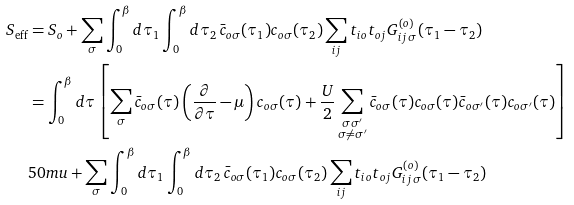Convert formula to latex. <formula><loc_0><loc_0><loc_500><loc_500>S _ { \text {eff} } & = S _ { o } + \sum _ { \sigma } \int _ { 0 } ^ { \beta } d \tau _ { 1 } \int _ { 0 } ^ { \beta } d \tau _ { 2 } \, \bar { c } _ { o \sigma } ( \tau _ { 1 } ) c _ { o \sigma } ( \tau _ { 2 } ) \sum _ { i j } t _ { i o } t _ { o j } G _ { i j \, \sigma } ^ { ( o ) } ( \tau _ { 1 } - \tau _ { 2 } ) \\ & = \int _ { 0 } ^ { \beta } d \tau \left [ \sum _ { \sigma } \bar { c } _ { o \sigma } ( \tau ) \left ( \frac { \partial } { \partial \tau } - \mu \right ) c _ { o \sigma } ( \tau ) + \frac { U } { 2 } \sum _ { \substack { \sigma \sigma ^ { \prime } \\ \sigma \neq \sigma ^ { \prime } } } \bar { c } _ { o \sigma } ( \tau ) c _ { o \sigma } ( \tau ) \bar { c } _ { o \sigma ^ { \prime } } ( \tau ) c _ { o \sigma ^ { \prime } } ( \tau ) \right ] \\ & { 5 0 m u } + \sum _ { \sigma } \int _ { 0 } ^ { \beta } d \tau _ { 1 } \int _ { 0 } ^ { \beta } d \tau _ { 2 } \, \bar { c } _ { o \sigma } ( \tau _ { 1 } ) c _ { o \sigma } ( \tau _ { 2 } ) \sum _ { i j } t _ { i o } t _ { o j } G _ { i j \, \sigma } ^ { ( o ) } ( \tau _ { 1 } - \tau _ { 2 } ) \\</formula> 